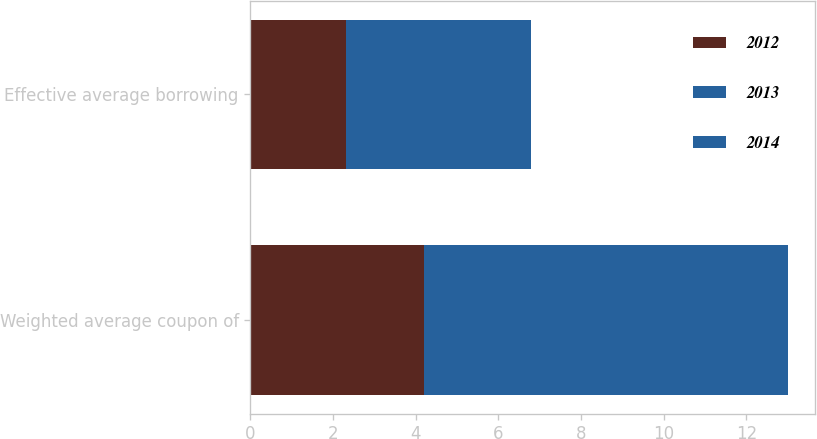<chart> <loc_0><loc_0><loc_500><loc_500><stacked_bar_chart><ecel><fcel>Weighted average coupon of<fcel>Effective average borrowing<nl><fcel>2012<fcel>4.2<fcel>2.3<nl><fcel>2013<fcel>4.4<fcel>2.2<nl><fcel>2014<fcel>4.4<fcel>2.3<nl></chart> 